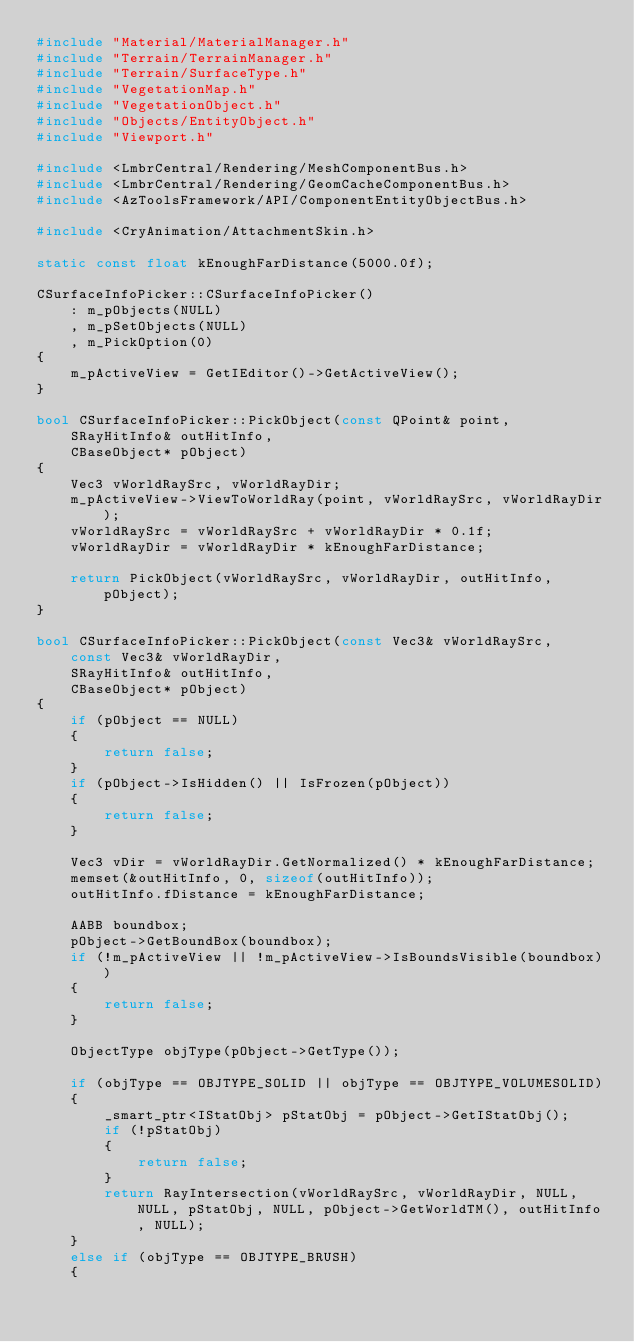Convert code to text. <code><loc_0><loc_0><loc_500><loc_500><_C++_>#include "Material/MaterialManager.h"
#include "Terrain/TerrainManager.h"
#include "Terrain/SurfaceType.h"
#include "VegetationMap.h"
#include "VegetationObject.h"
#include "Objects/EntityObject.h"
#include "Viewport.h"

#include <LmbrCentral/Rendering/MeshComponentBus.h>
#include <LmbrCentral/Rendering/GeomCacheComponentBus.h>
#include <AzToolsFramework/API/ComponentEntityObjectBus.h>

#include <CryAnimation/AttachmentSkin.h>

static const float kEnoughFarDistance(5000.0f);

CSurfaceInfoPicker::CSurfaceInfoPicker()
    : m_pObjects(NULL)
    , m_pSetObjects(NULL)
    , m_PickOption(0)
{
    m_pActiveView = GetIEditor()->GetActiveView();
}

bool CSurfaceInfoPicker::PickObject(const QPoint& point,
    SRayHitInfo& outHitInfo,
    CBaseObject* pObject)
{
    Vec3 vWorldRaySrc, vWorldRayDir;
    m_pActiveView->ViewToWorldRay(point, vWorldRaySrc, vWorldRayDir);
    vWorldRaySrc = vWorldRaySrc + vWorldRayDir * 0.1f;
    vWorldRayDir = vWorldRayDir * kEnoughFarDistance;

    return PickObject(vWorldRaySrc, vWorldRayDir, outHitInfo, pObject);
}

bool CSurfaceInfoPicker::PickObject(const Vec3& vWorldRaySrc,
    const Vec3& vWorldRayDir,
    SRayHitInfo& outHitInfo,
    CBaseObject* pObject)
{
    if (pObject == NULL)
    {
        return false;
    }
    if (pObject->IsHidden() || IsFrozen(pObject))
    {
        return false;
    }

    Vec3 vDir = vWorldRayDir.GetNormalized() * kEnoughFarDistance;
    memset(&outHitInfo, 0, sizeof(outHitInfo));
    outHitInfo.fDistance = kEnoughFarDistance;

    AABB boundbox;
    pObject->GetBoundBox(boundbox);
    if (!m_pActiveView || !m_pActiveView->IsBoundsVisible(boundbox))
    {
        return false;
    }

    ObjectType objType(pObject->GetType());

    if (objType == OBJTYPE_SOLID || objType == OBJTYPE_VOLUMESOLID)
    {
        _smart_ptr<IStatObj> pStatObj = pObject->GetIStatObj();
        if (!pStatObj)
        {
            return false;
        }
        return RayIntersection(vWorldRaySrc, vWorldRayDir, NULL, NULL, pStatObj, NULL, pObject->GetWorldTM(), outHitInfo, NULL);
    }
    else if (objType == OBJTYPE_BRUSH)
    {</code> 